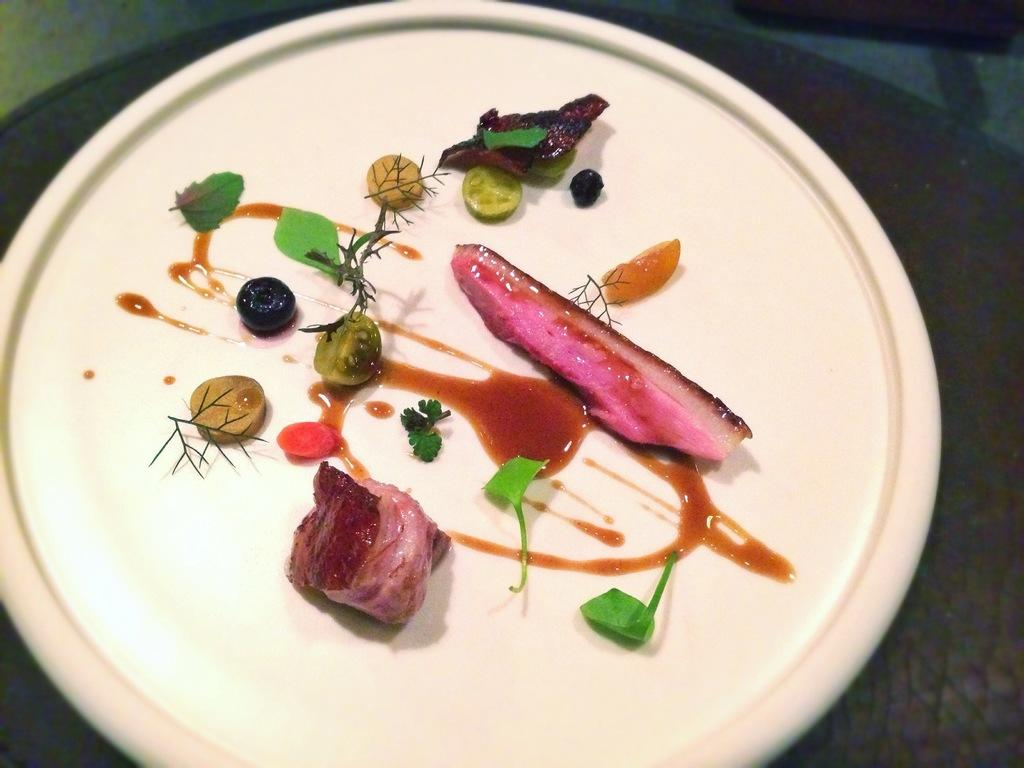What is on the plate in the image? There are food items on a plate. Where is the plate located in the image? The plate is placed on a surface. How many knots are tied on the fish in the image? There is no fish or knots present in the image. 